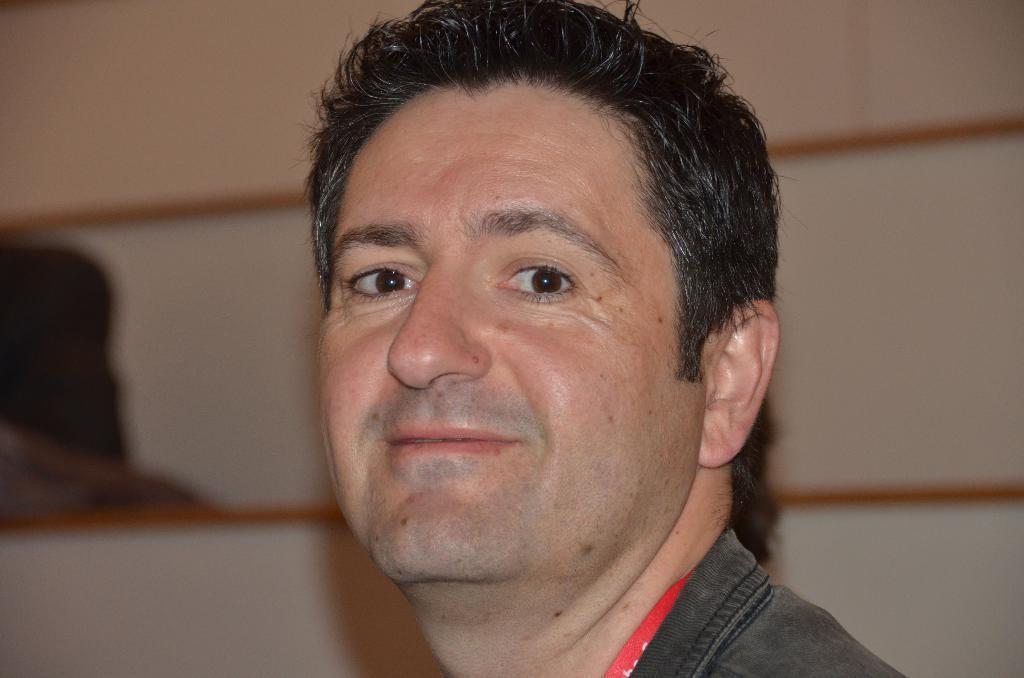In one or two sentences, can you explain what this image depicts? In this image, we can see a person face on the blur background. 